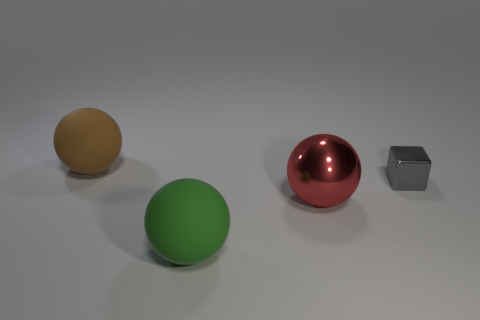Add 1 balls. How many objects exist? 5 Subtract all blue balls. Subtract all purple cylinders. How many balls are left? 3 Subtract all blocks. How many objects are left? 3 Subtract 0 cyan cylinders. How many objects are left? 4 Subtract all large green matte things. Subtract all metallic cubes. How many objects are left? 2 Add 1 red shiny spheres. How many red shiny spheres are left? 2 Add 4 big objects. How many big objects exist? 7 